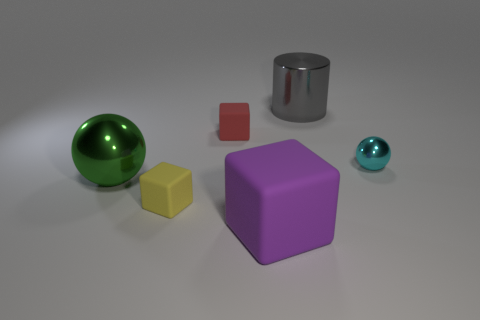The thing that is both behind the small metal sphere and on the left side of the large gray object has what shape?
Your answer should be compact. Cube. The yellow matte thing is what shape?
Ensure brevity in your answer.  Cube. There is a thing that is to the left of the tiny rubber block that is in front of the cyan ball; what color is it?
Your response must be concise. Green. What is the material of the large object that is both behind the yellow block and in front of the cyan metallic sphere?
Your answer should be very brief. Metal. Are there any green spheres that have the same size as the gray metallic object?
Your answer should be compact. Yes. There is a yellow cube that is the same size as the cyan sphere; what is it made of?
Your answer should be compact. Rubber. There is a tiny yellow matte cube; how many tiny yellow objects are on the right side of it?
Give a very brief answer. 0. There is a green thing that is behind the tiny yellow rubber cube; does it have the same shape as the large purple thing?
Ensure brevity in your answer.  No. Are there any cyan metallic things of the same shape as the small yellow object?
Offer a terse response. No. What shape is the large object that is behind the red object that is behind the small metal object?
Keep it short and to the point. Cylinder. 